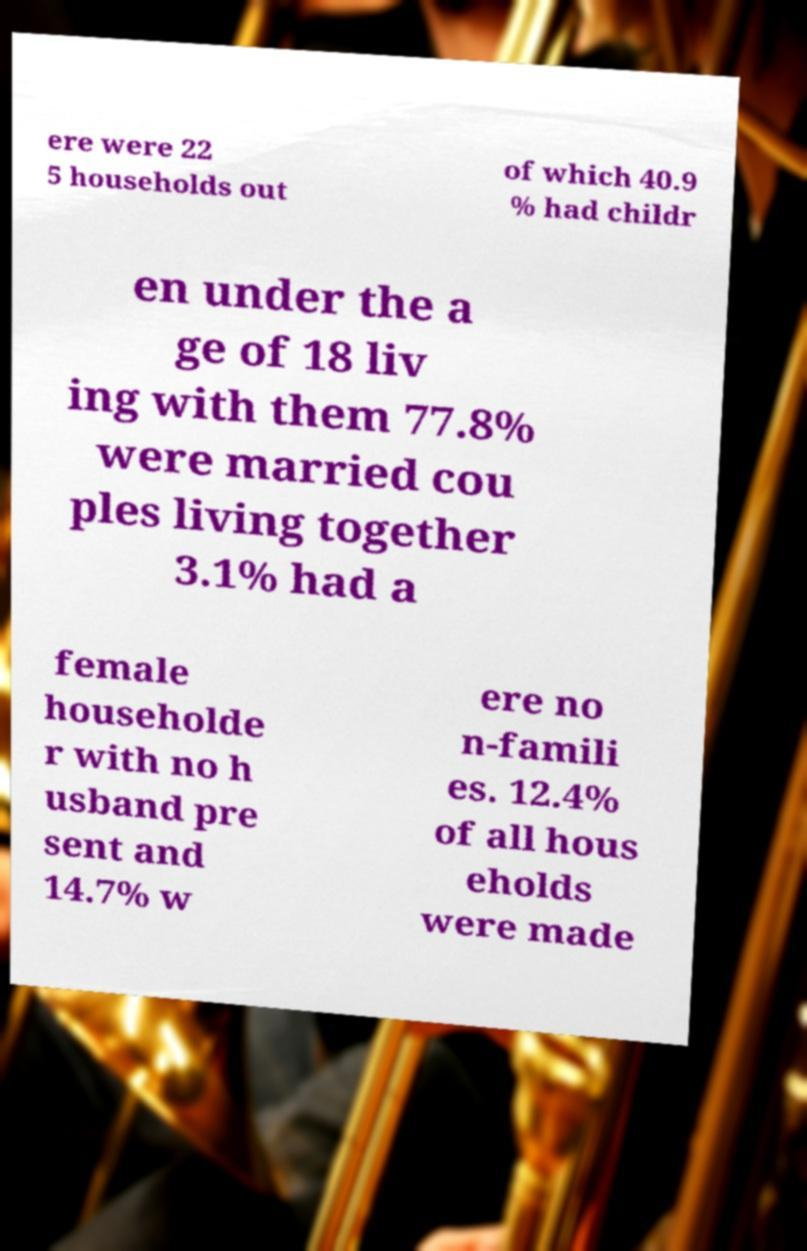For documentation purposes, I need the text within this image transcribed. Could you provide that? ere were 22 5 households out of which 40.9 % had childr en under the a ge of 18 liv ing with them 77.8% were married cou ples living together 3.1% had a female householde r with no h usband pre sent and 14.7% w ere no n-famili es. 12.4% of all hous eholds were made 